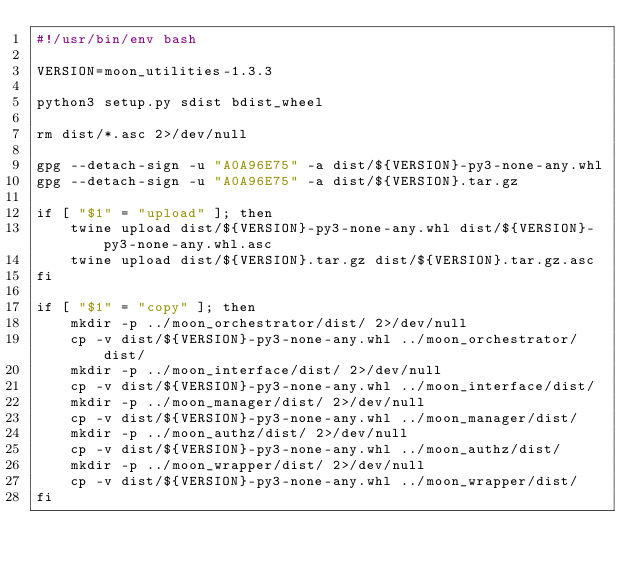Convert code to text. <code><loc_0><loc_0><loc_500><loc_500><_Bash_>#!/usr/bin/env bash

VERSION=moon_utilities-1.3.3

python3 setup.py sdist bdist_wheel

rm dist/*.asc 2>/dev/null

gpg --detach-sign -u "A0A96E75" -a dist/${VERSION}-py3-none-any.whl
gpg --detach-sign -u "A0A96E75" -a dist/${VERSION}.tar.gz

if [ "$1" = "upload" ]; then
    twine upload dist/${VERSION}-py3-none-any.whl dist/${VERSION}-py3-none-any.whl.asc
    twine upload dist/${VERSION}.tar.gz dist/${VERSION}.tar.gz.asc
fi

if [ "$1" = "copy" ]; then
    mkdir -p ../moon_orchestrator/dist/ 2>/dev/null
    cp -v dist/${VERSION}-py3-none-any.whl ../moon_orchestrator/dist/
    mkdir -p ../moon_interface/dist/ 2>/dev/null
    cp -v dist/${VERSION}-py3-none-any.whl ../moon_interface/dist/
    mkdir -p ../moon_manager/dist/ 2>/dev/null
    cp -v dist/${VERSION}-py3-none-any.whl ../moon_manager/dist/
    mkdir -p ../moon_authz/dist/ 2>/dev/null
    cp -v dist/${VERSION}-py3-none-any.whl ../moon_authz/dist/
    mkdir -p ../moon_wrapper/dist/ 2>/dev/null
    cp -v dist/${VERSION}-py3-none-any.whl ../moon_wrapper/dist/
fi
</code> 